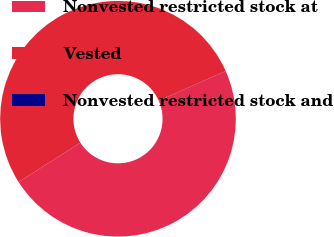Convert chart to OTSL. <chart><loc_0><loc_0><loc_500><loc_500><pie_chart><fcel>Nonvested restricted stock at<fcel>Vested<fcel>Nonvested restricted stock and<nl><fcel>47.62%<fcel>52.38%<fcel>0.01%<nl></chart> 